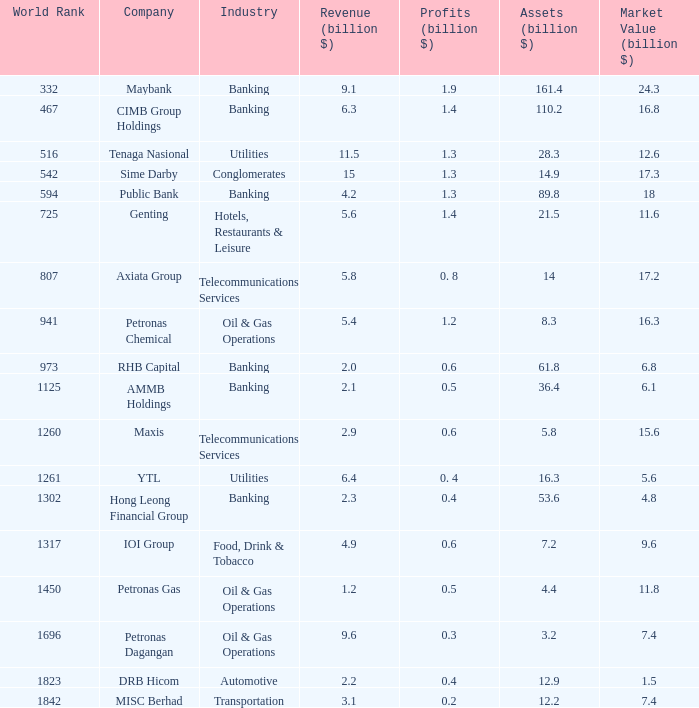Name the world rank for market value 17.2 807.0. 